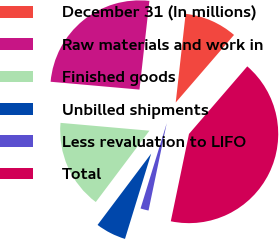<chart> <loc_0><loc_0><loc_500><loc_500><pie_chart><fcel>December 31 (In millions)<fcel>Raw materials and work in<fcel>Finished goods<fcel>Unbilled shipments<fcel>Less revaluation to LIFO<fcel>Total<nl><fcel>9.56%<fcel>25.37%<fcel>16.14%<fcel>5.52%<fcel>1.47%<fcel>41.94%<nl></chart> 